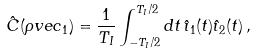Convert formula to latex. <formula><loc_0><loc_0><loc_500><loc_500>\hat { C } ( \rho v e c _ { 1 } ) = \frac { 1 } { T _ { I } } \int _ { - T _ { I } / 2 } ^ { T _ { I } / 2 } d t \, \hat { \imath } _ { 1 } ( t ) \hat { \imath } _ { 2 } ( t ) \, ,</formula> 